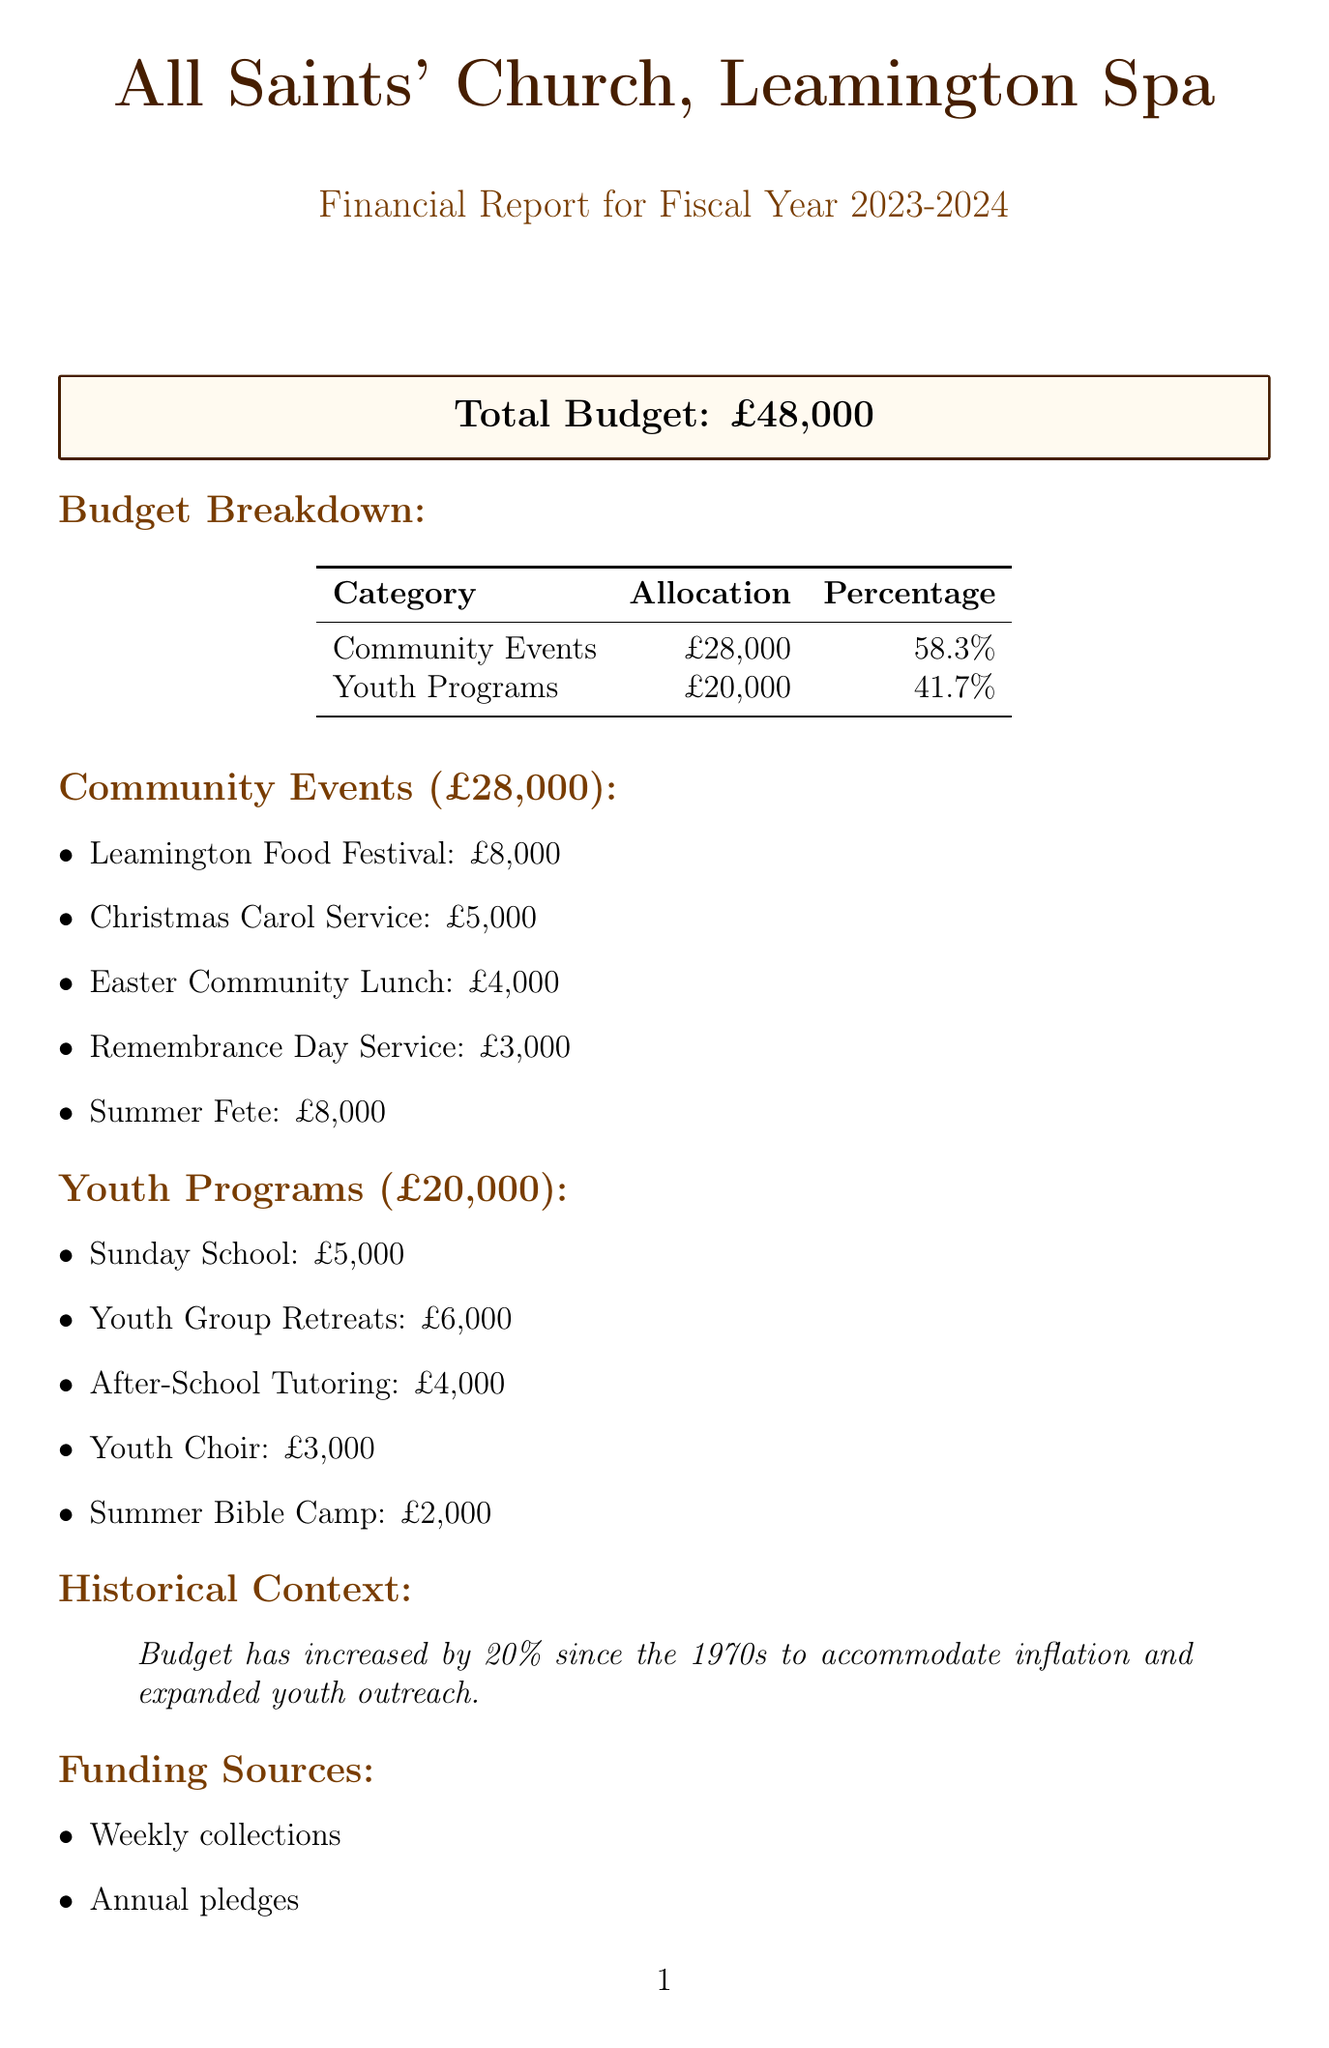What is the total budget? The total budget is specified at the beginning of the document for the fiscal year.
Answer: £48,000 How much is allocated for community events? The allocation for community events can be found in the budget breakdown section of the document.
Answer: £28,000 What is the budget for the Easter Community Lunch? The specific budget for the Easter Community Lunch is listed under the community events.
Answer: £4,000 Who approved the budget? The document mentions which bodies are responsible for the budget approval process.
Answer: Church Council and Parochial Church Council How much is budgeted for Sunday School? The budget for Sunday School is stated in the youth programs section of the document.
Answer: £5,000 What percentage of the total budget is allocated to youth programs? The document specifies the percentage allocation for youth programs.
Answer: 41.7% What is the historical context mentioned in the document? The historical context relates to the budget increase since the 1970s, as per the document.
Answer: Budget has increased by 20% since the 1970s What are the sources of funding listed? The document outlines the various sources of funding for the church's budget.
Answer: Weekly collections, Annual pledges, Grants from the Diocese of Coventry, Donations from local businesses What is the budget for the Summer Bible Camp? The budget allocated for the Summer Bible Camp is provided in the youth programs section.
Answer: £2,000 Who is the contact person for the budget report? The document specifies who to contact regarding the budget.
Answer: Rev. Sarah Thompson, Vicar of All Saints' Church 